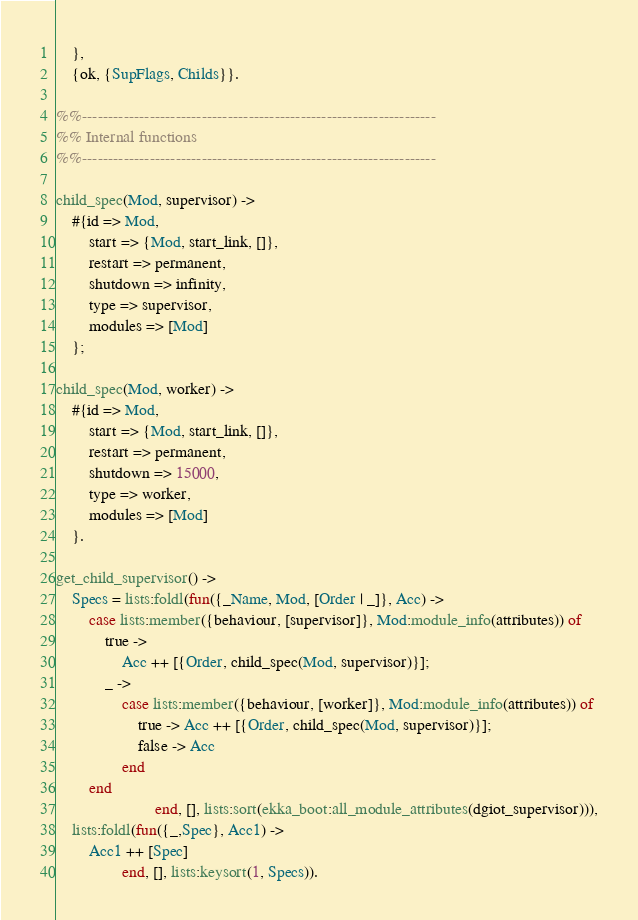Convert code to text. <code><loc_0><loc_0><loc_500><loc_500><_Erlang_>    },
    {ok, {SupFlags, Childs}}.

%%--------------------------------------------------------------------
%% Internal functions
%%--------------------------------------------------------------------

child_spec(Mod, supervisor) ->
    #{id => Mod,
        start => {Mod, start_link, []},
        restart => permanent,
        shutdown => infinity,
        type => supervisor,
        modules => [Mod]
    };

child_spec(Mod, worker) ->
    #{id => Mod,
        start => {Mod, start_link, []},
        restart => permanent,
        shutdown => 15000,
        type => worker,
        modules => [Mod]
    }.

get_child_supervisor() ->
    Specs = lists:foldl(fun({_Name, Mod, [Order | _]}, Acc) ->
        case lists:member({behaviour, [supervisor]}, Mod:module_info(attributes)) of
            true ->
                Acc ++ [{Order, child_spec(Mod, supervisor)}];
            _ ->
                case lists:member({behaviour, [worker]}, Mod:module_info(attributes)) of
                    true -> Acc ++ [{Order, child_spec(Mod, supervisor)}];
                    false -> Acc
                end
        end
                        end, [], lists:sort(ekka_boot:all_module_attributes(dgiot_supervisor))),
    lists:foldl(fun({_,Spec}, Acc1) ->
        Acc1 ++ [Spec]
                end, [], lists:keysort(1, Specs)).


</code> 